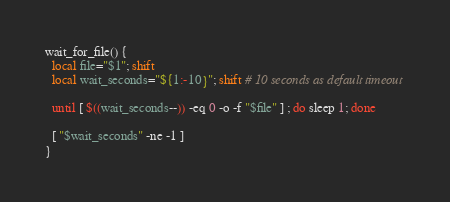<code> <loc_0><loc_0><loc_500><loc_500><_Bash_>wait_for_file() {
  local file="$1"; shift
  local wait_seconds="${1:-10}"; shift # 10 seconds as default timeout

  until [ $((wait_seconds--)) -eq 0 -o -f "$file" ] ; do sleep 1; done

  [ "$wait_seconds" -ne -1 ]
}
</code> 